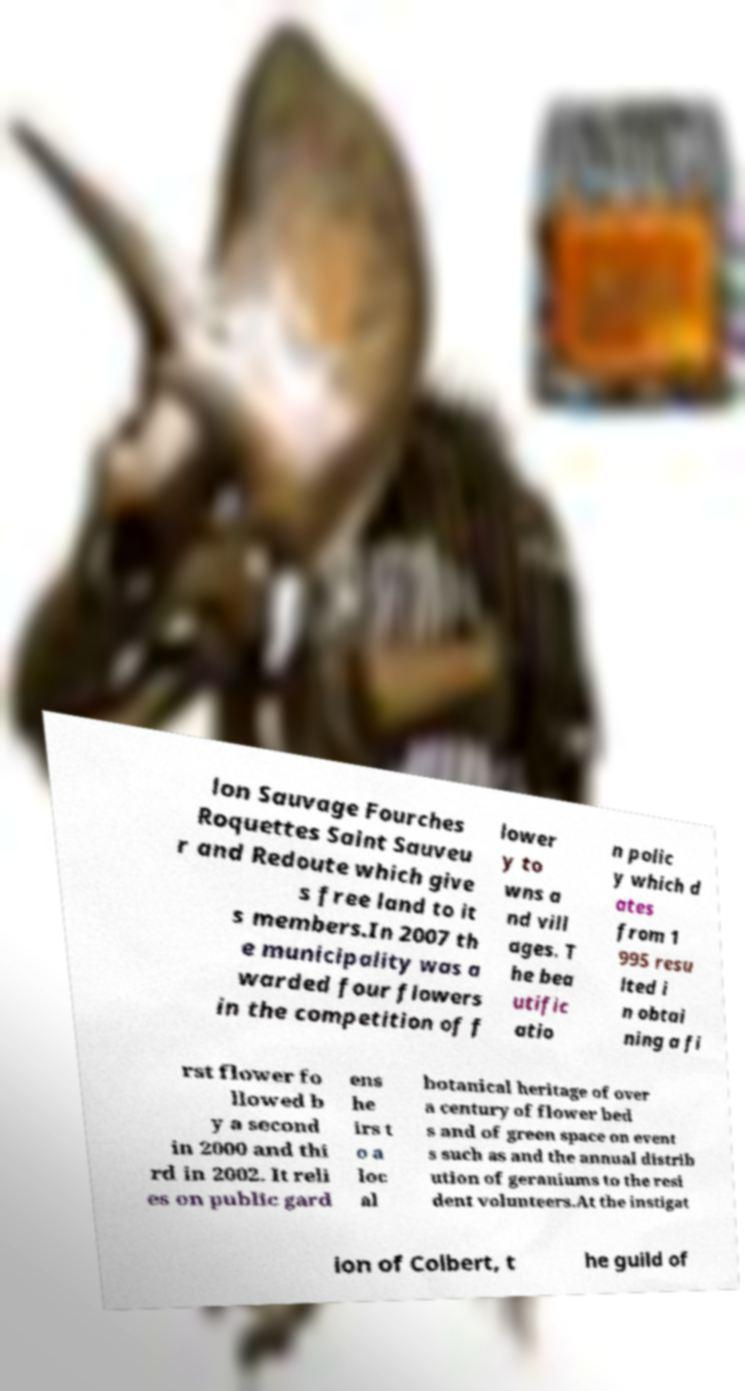I need the written content from this picture converted into text. Can you do that? lon Sauvage Fourches Roquettes Saint Sauveu r and Redoute which give s free land to it s members.In 2007 th e municipality was a warded four flowers in the competition of f lower y to wns a nd vill ages. T he bea utific atio n polic y which d ates from 1 995 resu lted i n obtai ning a fi rst flower fo llowed b y a second in 2000 and thi rd in 2002. It reli es on public gard ens he irs t o a loc al botanical heritage of over a century of flower bed s and of green space on event s such as and the annual distrib ution of geraniums to the resi dent volunteers.At the instigat ion of Colbert, t he guild of 